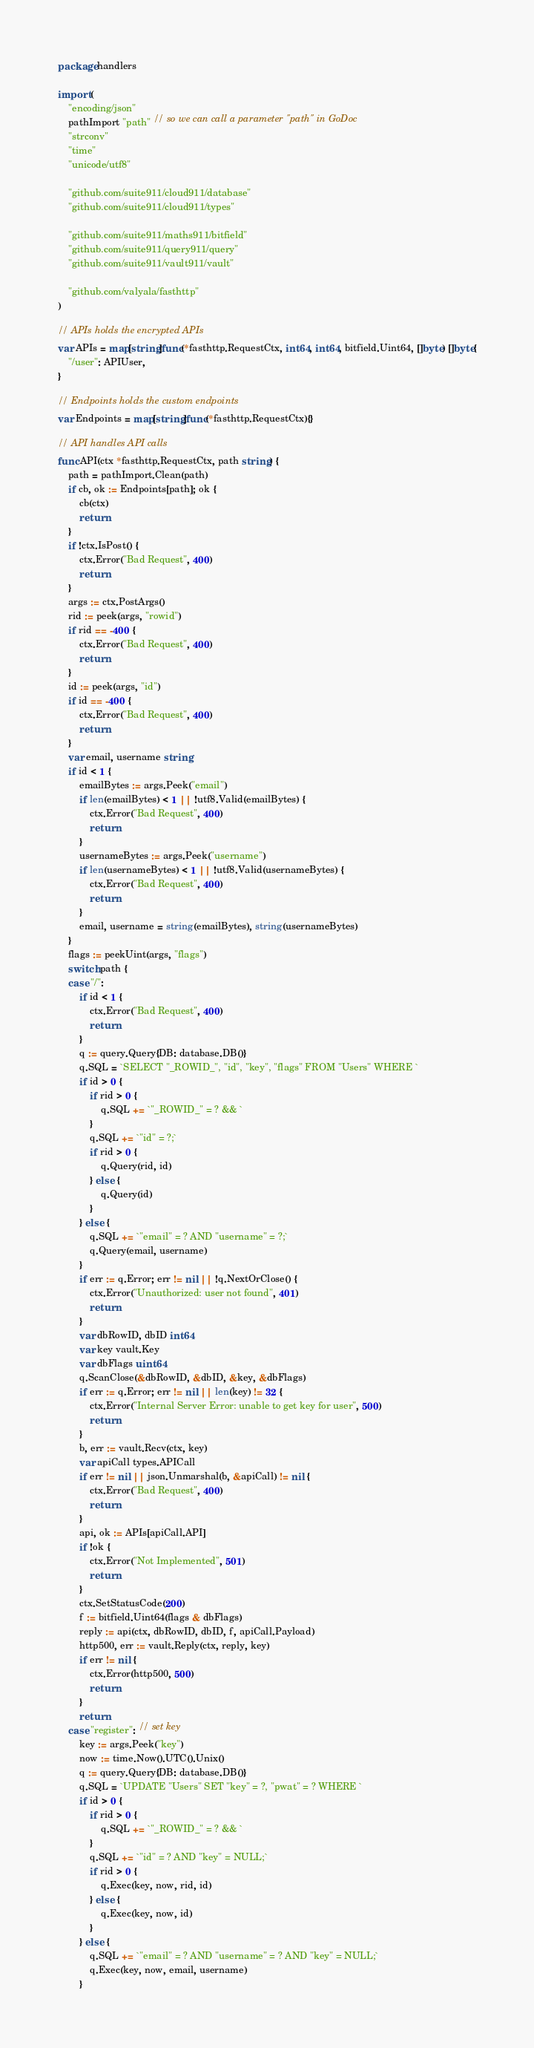<code> <loc_0><loc_0><loc_500><loc_500><_Go_>package handlers

import (
	"encoding/json"
	pathImport "path" // so we can call a parameter "path" in GoDoc
	"strconv"
	"time"
	"unicode/utf8"

	"github.com/suite911/cloud911/database"
	"github.com/suite911/cloud911/types"

	"github.com/suite911/maths911/bitfield"
	"github.com/suite911/query911/query"
	"github.com/suite911/vault911/vault"

	"github.com/valyala/fasthttp"
)

// APIs holds the encrypted APIs
var APIs = map[string]func(*fasthttp.RequestCtx, int64, int64, bitfield.Uint64, []byte) []byte{
	"/user": APIUser,
}

// Endpoints holds the custom endpoints
var Endpoints = map[string]func(*fasthttp.RequestCtx){}

// API handles API calls
func API(ctx *fasthttp.RequestCtx, path string) {
	path = pathImport.Clean(path)
	if cb, ok := Endpoints[path]; ok {
		cb(ctx)
		return
	}
	if !ctx.IsPost() {
		ctx.Error("Bad Request", 400)
		return
	}
	args := ctx.PostArgs()
	rid := peek(args, "rowid")
	if rid == -400 {
		ctx.Error("Bad Request", 400)
		return
	}
	id := peek(args, "id")
	if id == -400 {
		ctx.Error("Bad Request", 400)
		return
	}
	var email, username string
	if id < 1 {
		emailBytes := args.Peek("email")
		if len(emailBytes) < 1 || !utf8.Valid(emailBytes) {
			ctx.Error("Bad Request", 400)
			return
		}
		usernameBytes := args.Peek("username")
		if len(usernameBytes) < 1 || !utf8.Valid(usernameBytes) {
			ctx.Error("Bad Request", 400)
			return
		}
		email, username = string(emailBytes), string(usernameBytes)
	}
	flags := peekUint(args, "flags")
	switch path {
	case "/":
		if id < 1 {
			ctx.Error("Bad Request", 400)
			return
		}
		q := query.Query{DB: database.DB()}
		q.SQL = `SELECT "_ROWID_", "id", "key", "flags" FROM "Users" WHERE `
		if id > 0 {
			if rid > 0 {
				q.SQL += `"_ROWID_" = ? && `
			}
			q.SQL += `"id" = ?;`
			if rid > 0 {
				q.Query(rid, id)
			} else {
				q.Query(id)
			}
		} else {
			q.SQL += `"email" = ? AND "username" = ?;`
			q.Query(email, username)
		}
		if err := q.Error; err != nil || !q.NextOrClose() {
			ctx.Error("Unauthorized: user not found", 401)
			return
		}
		var dbRowID, dbID int64
		var key vault.Key
		var dbFlags uint64
		q.ScanClose(&dbRowID, &dbID, &key, &dbFlags)
		if err := q.Error; err != nil || len(key) != 32 {
			ctx.Error("Internal Server Error: unable to get key for user", 500)
			return
		}
		b, err := vault.Recv(ctx, key)
		var apiCall types.APICall
		if err != nil || json.Unmarshal(b, &apiCall) != nil {
			ctx.Error("Bad Request", 400)
			return
		}
		api, ok := APIs[apiCall.API]
		if !ok {
			ctx.Error("Not Implemented", 501)
			return
		}
		ctx.SetStatusCode(200)
		f := bitfield.Uint64(flags & dbFlags)
		reply := api(ctx, dbRowID, dbID, f, apiCall.Payload)
		http500, err := vault.Reply(ctx, reply, key)
		if err != nil {
			ctx.Error(http500, 500)
			return
		}
		return
	case "register": // set key
		key := args.Peek("key")
		now := time.Now().UTC().Unix()
		q := query.Query{DB: database.DB()}
		q.SQL = `UPDATE "Users" SET "key" = ?, "pwat" = ? WHERE `
		if id > 0 {
			if rid > 0 {
				q.SQL += `"_ROWID_" = ? && `
			}
			q.SQL += `"id" = ? AND "key" = NULL;`
			if rid > 0 {
				q.Exec(key, now, rid, id)
			} else {
				q.Exec(key, now, id)
			}
		} else {
			q.SQL += `"email" = ? AND "username" = ? AND "key" = NULL;`
			q.Exec(key, now, email, username)
		}</code> 